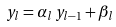Convert formula to latex. <formula><loc_0><loc_0><loc_500><loc_500>y _ { l } = \alpha _ { l } \, y _ { l - 1 } + \beta _ { l }</formula> 